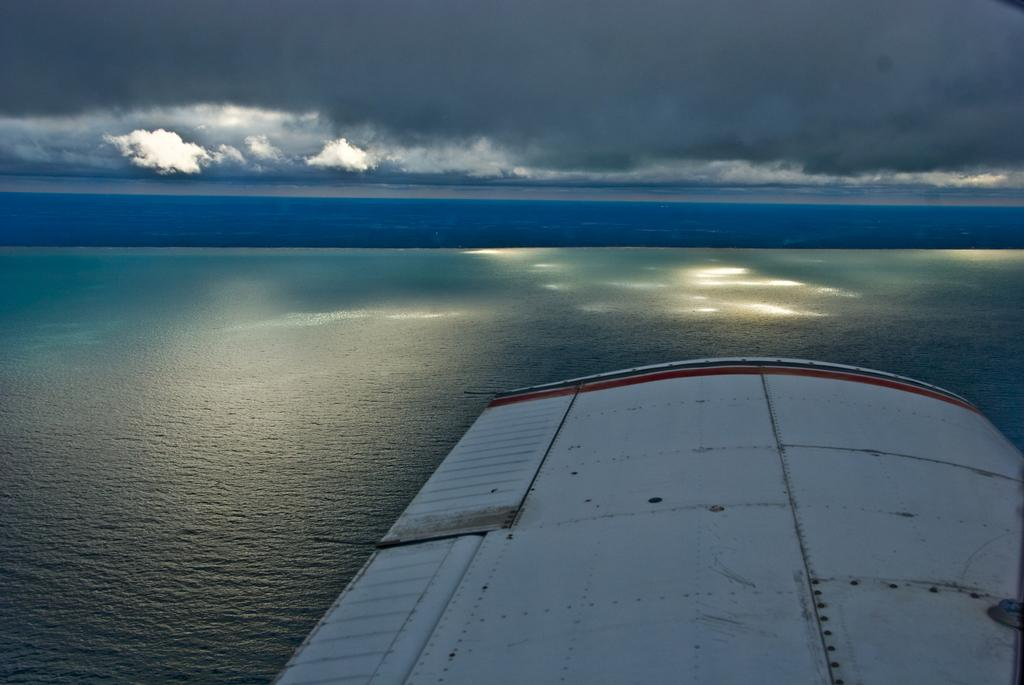What is present at the bottom of the image? There is water at the bottom of the image. What is visible at the top of the image? There is sky at the top of the image. Where is the roof located in the image? The roof is in the bottom right side of the image. What type of straw is being used to play volleyball in the image? There is no straw or volleyball present in the image. What part of the roof is visible in the image? The provided facts do not specify a particular part of the roof that is visible; only the presence of a roof in the bottom right side is mentioned. 